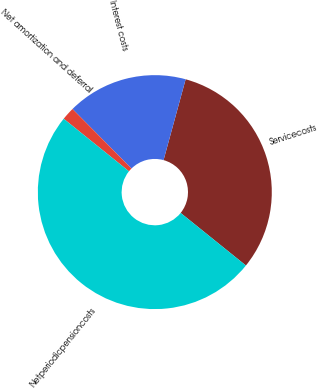Convert chart to OTSL. <chart><loc_0><loc_0><loc_500><loc_500><pie_chart><fcel>Servicecosts<fcel>Interest costs<fcel>Net amortization and deferral<fcel>Netperiodicpensioncosts<nl><fcel>31.55%<fcel>16.67%<fcel>1.79%<fcel>50.0%<nl></chart> 